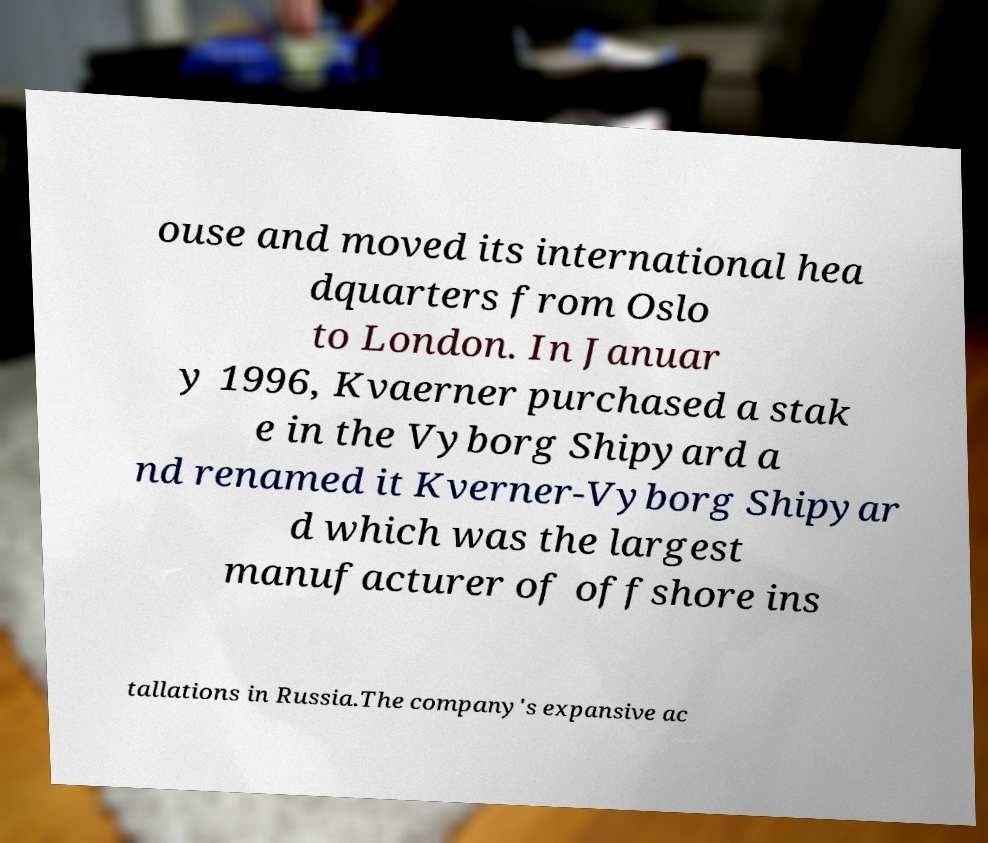There's text embedded in this image that I need extracted. Can you transcribe it verbatim? ouse and moved its international hea dquarters from Oslo to London. In Januar y 1996, Kvaerner purchased a stak e in the Vyborg Shipyard a nd renamed it Kverner-Vyborg Shipyar d which was the largest manufacturer of offshore ins tallations in Russia.The company's expansive ac 